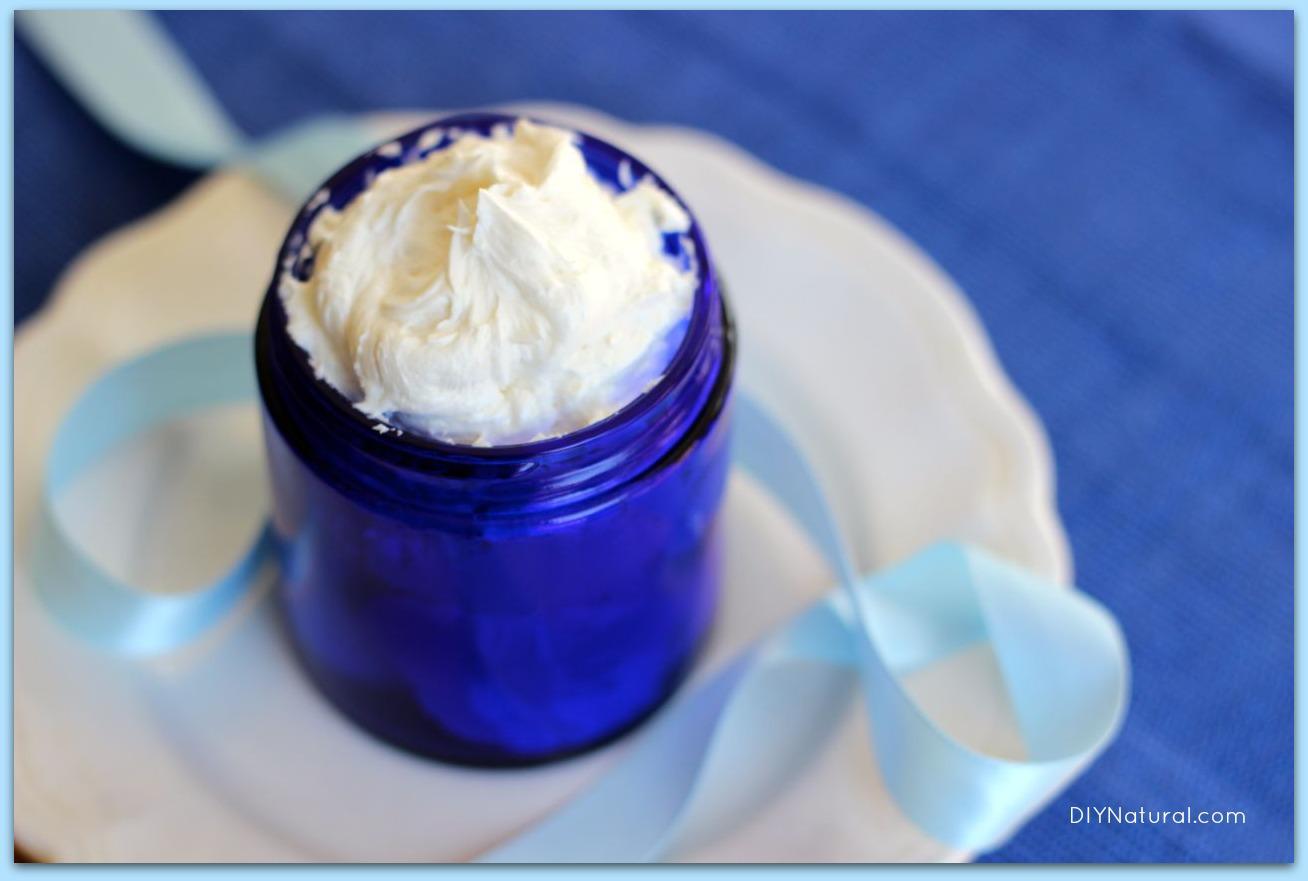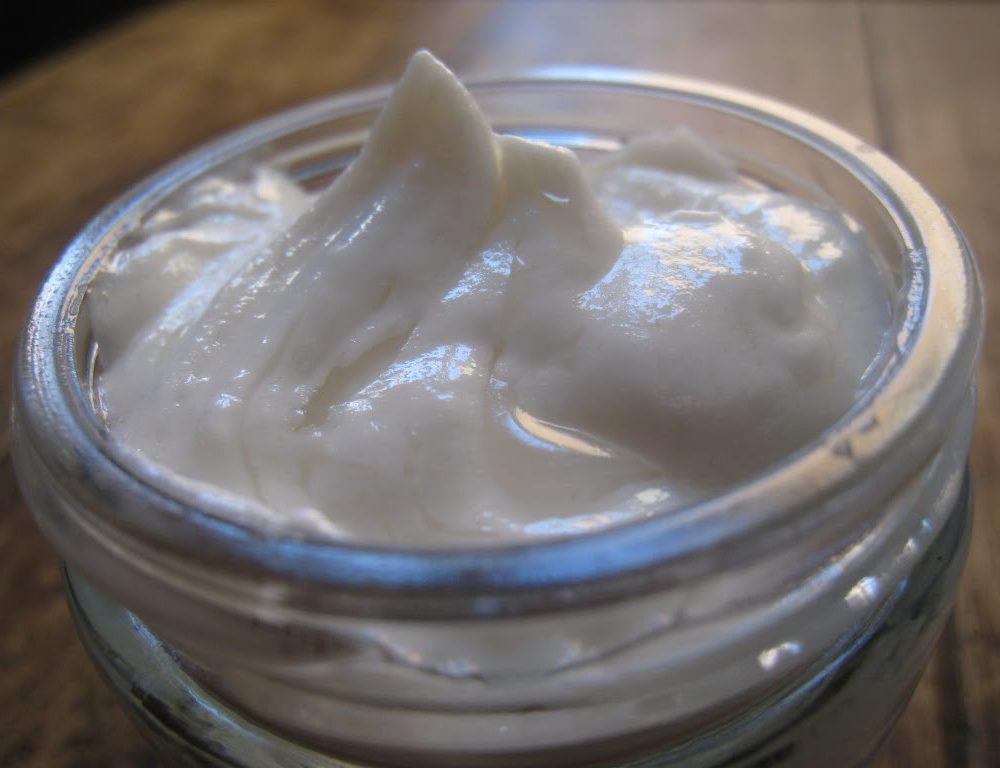The first image is the image on the left, the second image is the image on the right. Examine the images to the left and right. Is the description "There is a white lotion in one image and a yellow lotion in the other." accurate? Answer yes or no. No. The first image is the image on the left, the second image is the image on the right. Analyze the images presented: Is the assertion "An image shows an open jar filled with white creamy concoction, sitting on a wood-grain surface." valid? Answer yes or no. Yes. 